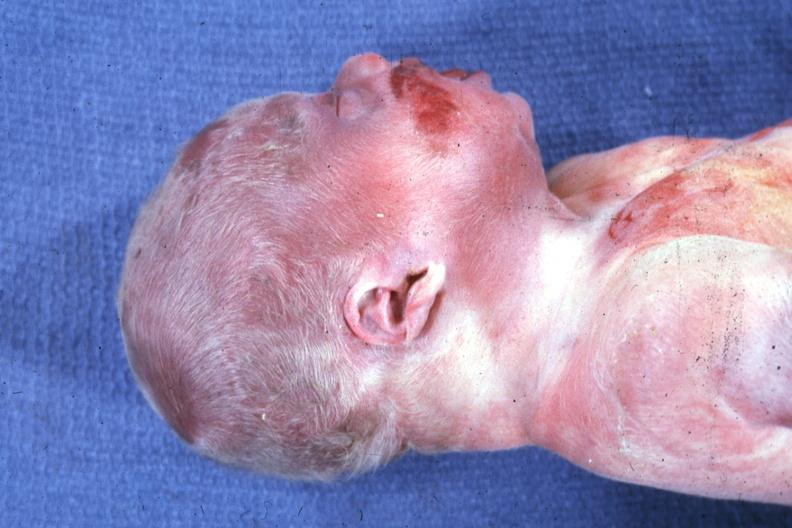s beckwith-wiedemann syndrome present?
Answer the question using a single word or phrase. Yes 